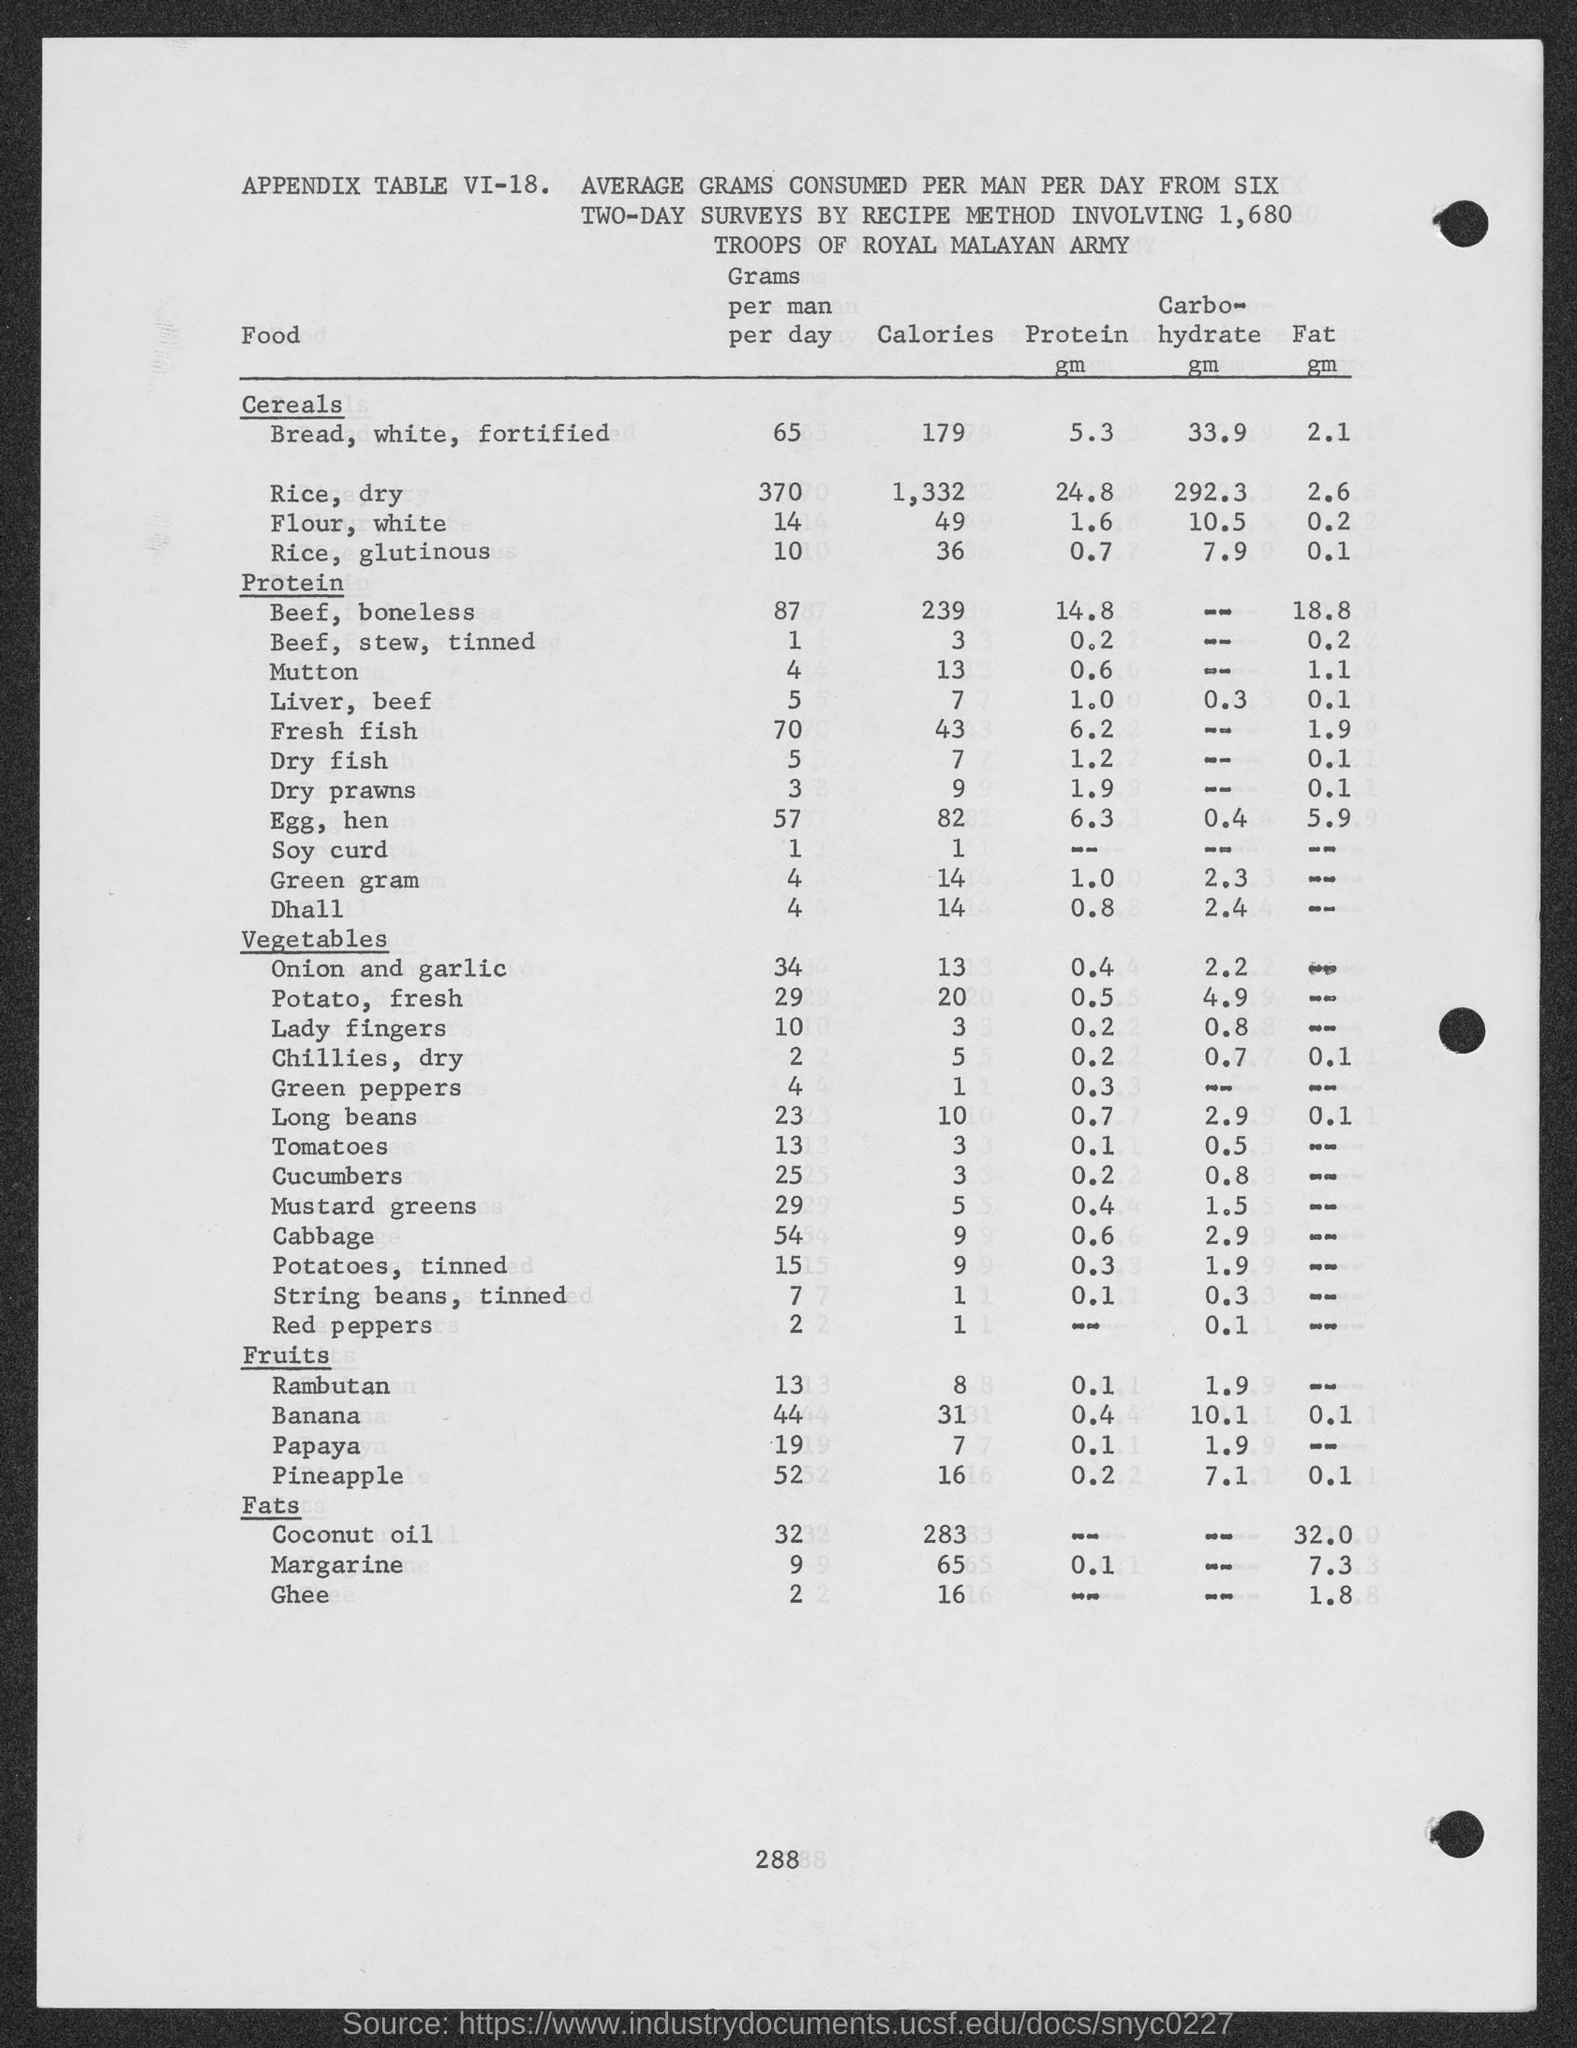Give some essential details in this illustration. The caloric value of beef, boneless is 239. The caloric content of glutinous rice is 36. The caloric content of dry fish is 7... The calorie content for liver from beef is 7. The caloric content of mutton is 13. 